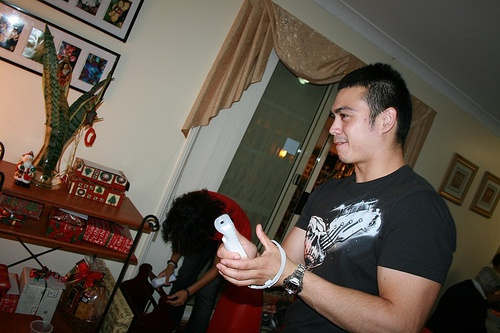Describe the objects in this image and their specific colors. I can see people in black, tan, and gray tones, people in black, maroon, gray, and darkgray tones, people in black tones, vase in black, maroon, and brown tones, and remote in black, lightgray, lightblue, and darkgray tones in this image. 